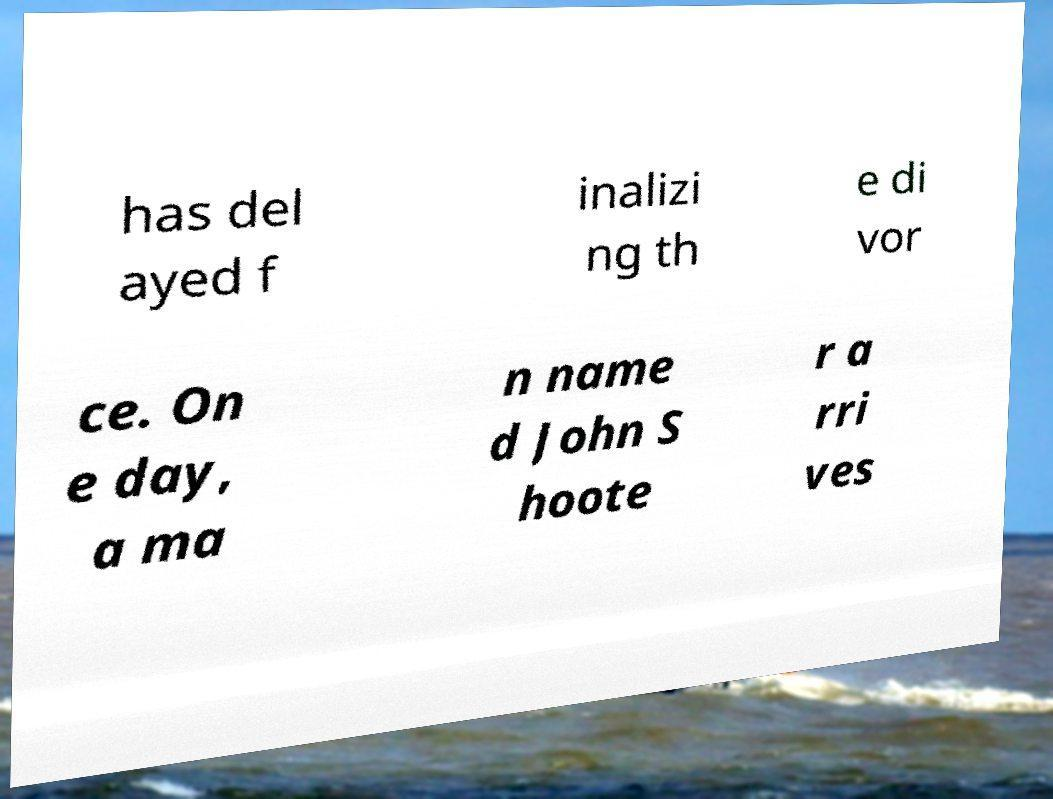Can you accurately transcribe the text from the provided image for me? has del ayed f inalizi ng th e di vor ce. On e day, a ma n name d John S hoote r a rri ves 